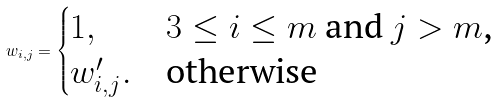Convert formula to latex. <formula><loc_0><loc_0><loc_500><loc_500>w _ { i , j } = \begin{cases} 1 , & \text {$3\leq i\leq m$ and $j>m$,} \\ w ^ { \prime } _ { i , j } . & \text {otherwise} \end{cases}</formula> 